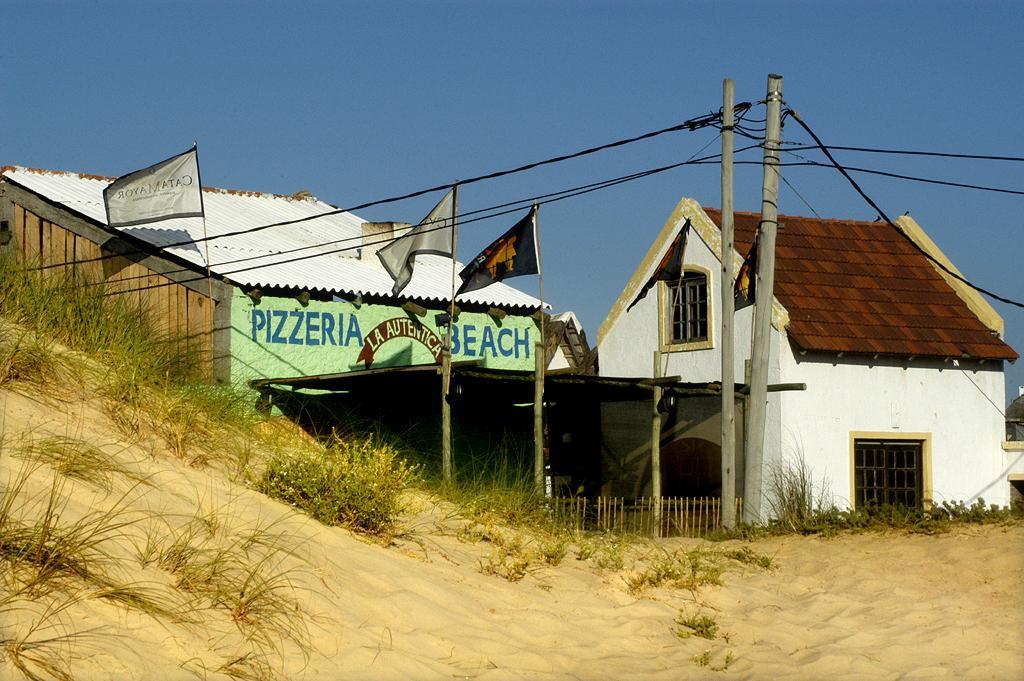How would you summarize this image in a sentence or two? In this image there are two houses. Image also consists of flags and electrical poles with wires. At the top there is sky and at the bottom there is sand with grass. 